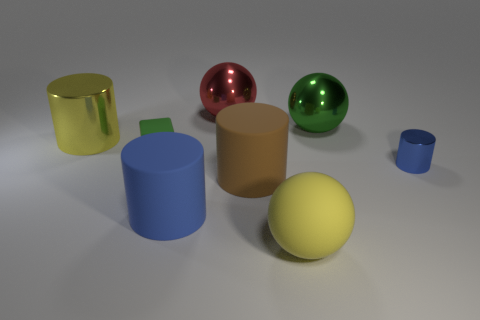Is the shape of the red thing the same as the small matte thing? No, the red object is a sphere, while the small matte object appears to be a cylinder with a circular top. 